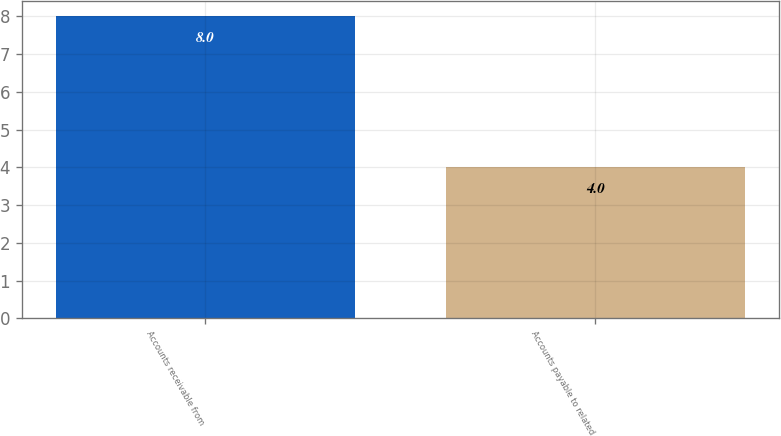Convert chart. <chart><loc_0><loc_0><loc_500><loc_500><bar_chart><fcel>Accounts receivable from<fcel>Accounts payable to related<nl><fcel>8<fcel>4<nl></chart> 